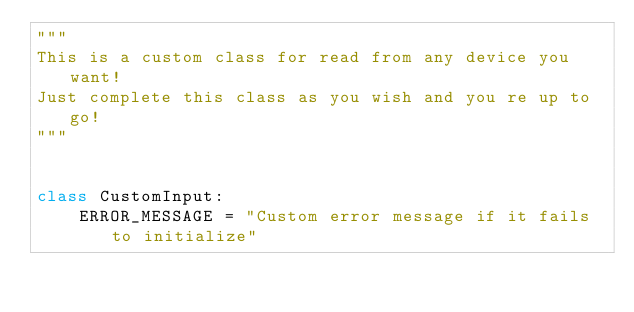Convert code to text. <code><loc_0><loc_0><loc_500><loc_500><_Python_>"""
This is a custom class for read from any device you want!
Just complete this class as you wish and you re up to go!
"""


class CustomInput:
    ERROR_MESSAGE = "Custom error message if it fails to initialize"
</code> 